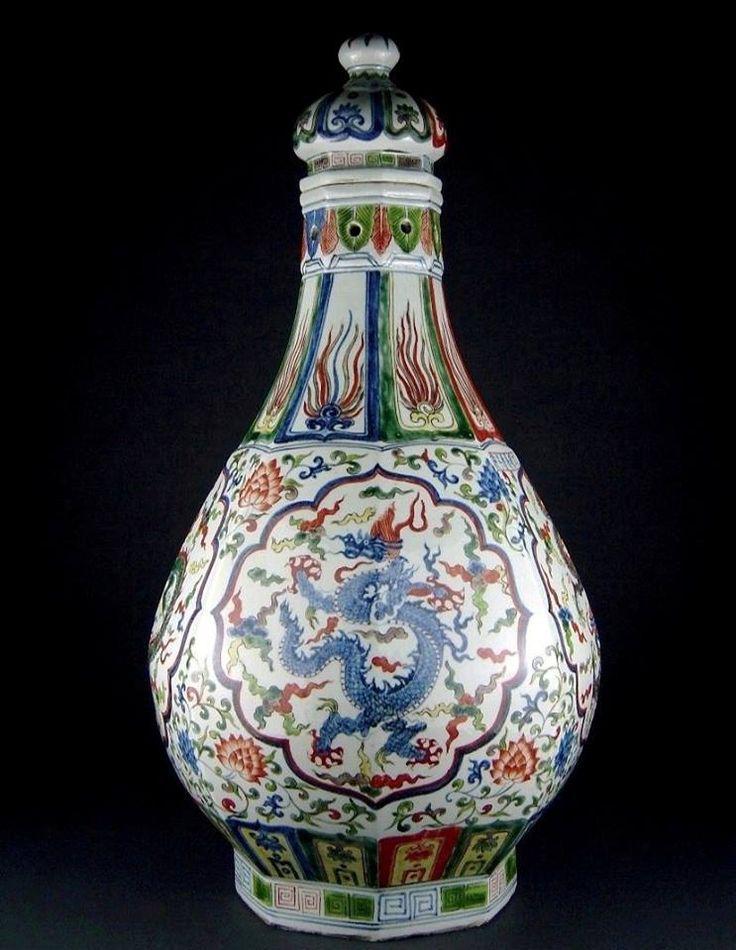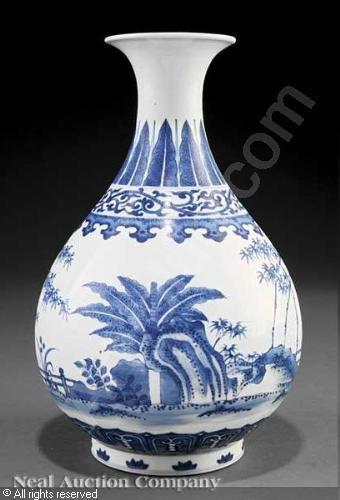The first image is the image on the left, the second image is the image on the right. Assess this claim about the two images: "The left image features a vase with a round midsection and a dragon depicted in blue on its front.". Correct or not? Answer yes or no. Yes. The first image is the image on the left, the second image is the image on the right. Examine the images to the left and right. Is the description "In the left image, the artwork appears to include a dragon." accurate? Answer yes or no. Yes. 